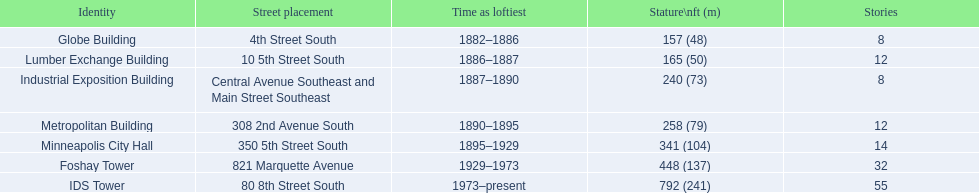What are all the building names? Globe Building, Lumber Exchange Building, Industrial Exposition Building, Metropolitan Building, Minneapolis City Hall, Foshay Tower, IDS Tower. And their heights? 157 (48), 165 (50), 240 (73), 258 (79), 341 (104), 448 (137), 792 (241). Between metropolitan building and lumber exchange building, which is taller? Metropolitan Building. 